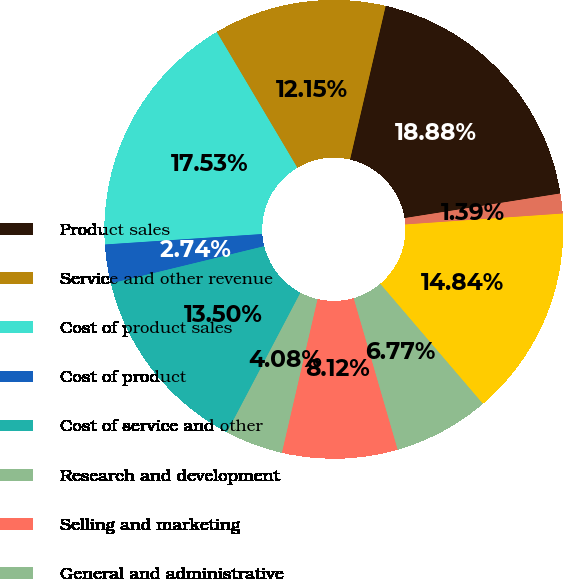Convert chart. <chart><loc_0><loc_0><loc_500><loc_500><pie_chart><fcel>Product sales<fcel>Service and other revenue<fcel>Cost of product sales<fcel>Cost of product<fcel>Cost of service and other<fcel>Research and development<fcel>Selling and marketing<fcel>General and administrative<fcel>Income from operations<fcel>Interest income<nl><fcel>18.88%<fcel>12.15%<fcel>17.53%<fcel>2.74%<fcel>13.5%<fcel>4.08%<fcel>8.12%<fcel>6.77%<fcel>14.84%<fcel>1.39%<nl></chart> 